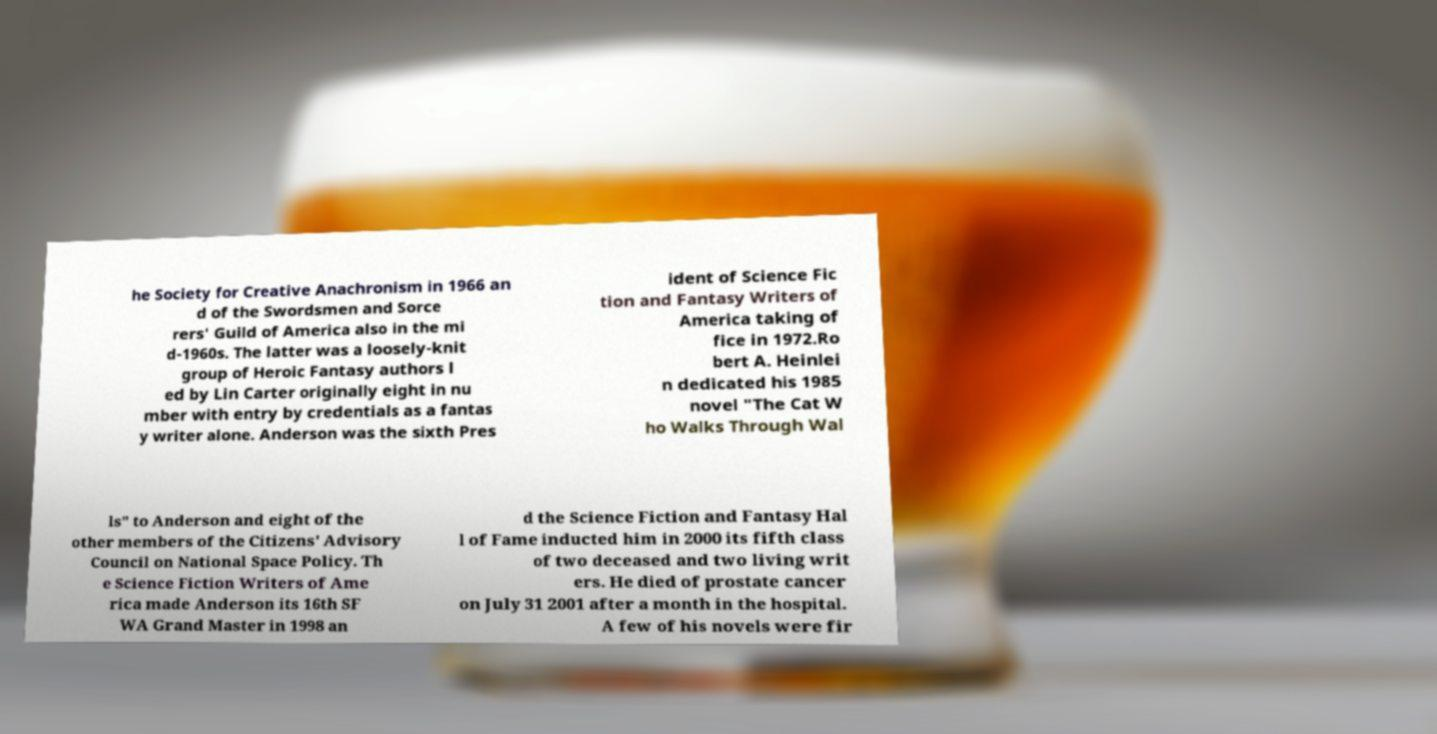There's text embedded in this image that I need extracted. Can you transcribe it verbatim? he Society for Creative Anachronism in 1966 an d of the Swordsmen and Sorce rers' Guild of America also in the mi d-1960s. The latter was a loosely-knit group of Heroic Fantasy authors l ed by Lin Carter originally eight in nu mber with entry by credentials as a fantas y writer alone. Anderson was the sixth Pres ident of Science Fic tion and Fantasy Writers of America taking of fice in 1972.Ro bert A. Heinlei n dedicated his 1985 novel "The Cat W ho Walks Through Wal ls" to Anderson and eight of the other members of the Citizens' Advisory Council on National Space Policy. Th e Science Fiction Writers of Ame rica made Anderson its 16th SF WA Grand Master in 1998 an d the Science Fiction and Fantasy Hal l of Fame inducted him in 2000 its fifth class of two deceased and two living writ ers. He died of prostate cancer on July 31 2001 after a month in the hospital. A few of his novels were fir 